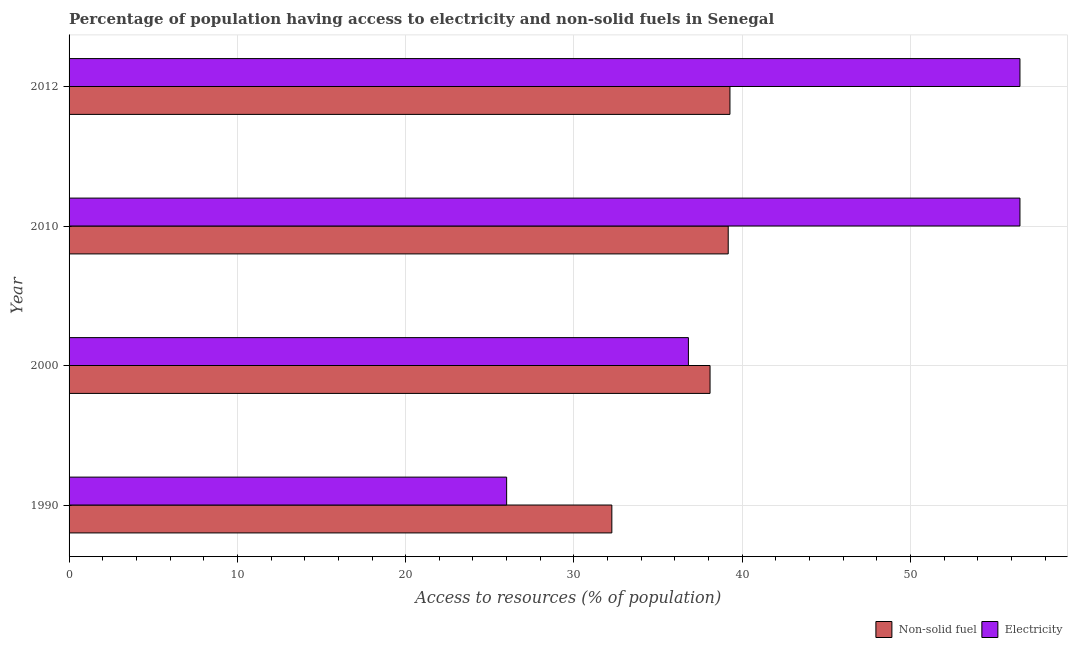Are the number of bars on each tick of the Y-axis equal?
Your answer should be very brief. Yes. How many bars are there on the 4th tick from the top?
Ensure brevity in your answer.  2. What is the percentage of population having access to non-solid fuel in 2012?
Offer a very short reply. 39.27. Across all years, what is the maximum percentage of population having access to electricity?
Offer a very short reply. 56.5. Across all years, what is the minimum percentage of population having access to non-solid fuel?
Make the answer very short. 32.25. What is the total percentage of population having access to electricity in the graph?
Make the answer very short. 175.8. What is the difference between the percentage of population having access to non-solid fuel in 2010 and that in 2012?
Keep it short and to the point. -0.1. What is the difference between the percentage of population having access to non-solid fuel in 2012 and the percentage of population having access to electricity in 1990?
Keep it short and to the point. 13.27. What is the average percentage of population having access to electricity per year?
Your answer should be compact. 43.95. In the year 2012, what is the difference between the percentage of population having access to non-solid fuel and percentage of population having access to electricity?
Ensure brevity in your answer.  -17.23. What is the ratio of the percentage of population having access to non-solid fuel in 2000 to that in 2012?
Your answer should be compact. 0.97. Is the percentage of population having access to non-solid fuel in 2000 less than that in 2012?
Make the answer very short. Yes. Is the difference between the percentage of population having access to non-solid fuel in 1990 and 2010 greater than the difference between the percentage of population having access to electricity in 1990 and 2010?
Ensure brevity in your answer.  Yes. What is the difference between the highest and the second highest percentage of population having access to non-solid fuel?
Offer a very short reply. 0.1. What is the difference between the highest and the lowest percentage of population having access to electricity?
Offer a terse response. 30.5. What does the 1st bar from the top in 2012 represents?
Offer a terse response. Electricity. What does the 2nd bar from the bottom in 2000 represents?
Provide a succinct answer. Electricity. How many bars are there?
Your answer should be compact. 8. Are all the bars in the graph horizontal?
Your answer should be very brief. Yes. How many years are there in the graph?
Your answer should be compact. 4. Does the graph contain any zero values?
Offer a terse response. No. How many legend labels are there?
Offer a very short reply. 2. How are the legend labels stacked?
Keep it short and to the point. Horizontal. What is the title of the graph?
Offer a terse response. Percentage of population having access to electricity and non-solid fuels in Senegal. What is the label or title of the X-axis?
Give a very brief answer. Access to resources (% of population). What is the label or title of the Y-axis?
Offer a very short reply. Year. What is the Access to resources (% of population) in Non-solid fuel in 1990?
Your answer should be compact. 32.25. What is the Access to resources (% of population) in Electricity in 1990?
Offer a very short reply. 26. What is the Access to resources (% of population) in Non-solid fuel in 2000?
Provide a short and direct response. 38.09. What is the Access to resources (% of population) in Electricity in 2000?
Your response must be concise. 36.8. What is the Access to resources (% of population) of Non-solid fuel in 2010?
Give a very brief answer. 39.17. What is the Access to resources (% of population) in Electricity in 2010?
Your response must be concise. 56.5. What is the Access to resources (% of population) in Non-solid fuel in 2012?
Give a very brief answer. 39.27. What is the Access to resources (% of population) in Electricity in 2012?
Provide a short and direct response. 56.5. Across all years, what is the maximum Access to resources (% of population) of Non-solid fuel?
Your response must be concise. 39.27. Across all years, what is the maximum Access to resources (% of population) of Electricity?
Offer a very short reply. 56.5. Across all years, what is the minimum Access to resources (% of population) of Non-solid fuel?
Your response must be concise. 32.25. What is the total Access to resources (% of population) in Non-solid fuel in the graph?
Your response must be concise. 148.77. What is the total Access to resources (% of population) in Electricity in the graph?
Give a very brief answer. 175.8. What is the difference between the Access to resources (% of population) of Non-solid fuel in 1990 and that in 2000?
Provide a short and direct response. -5.83. What is the difference between the Access to resources (% of population) of Electricity in 1990 and that in 2000?
Provide a short and direct response. -10.8. What is the difference between the Access to resources (% of population) of Non-solid fuel in 1990 and that in 2010?
Your answer should be compact. -6.91. What is the difference between the Access to resources (% of population) of Electricity in 1990 and that in 2010?
Make the answer very short. -30.5. What is the difference between the Access to resources (% of population) of Non-solid fuel in 1990 and that in 2012?
Provide a succinct answer. -7.02. What is the difference between the Access to resources (% of population) in Electricity in 1990 and that in 2012?
Provide a succinct answer. -30.5. What is the difference between the Access to resources (% of population) of Non-solid fuel in 2000 and that in 2010?
Provide a succinct answer. -1.08. What is the difference between the Access to resources (% of population) of Electricity in 2000 and that in 2010?
Provide a succinct answer. -19.7. What is the difference between the Access to resources (% of population) of Non-solid fuel in 2000 and that in 2012?
Give a very brief answer. -1.18. What is the difference between the Access to resources (% of population) in Electricity in 2000 and that in 2012?
Offer a terse response. -19.7. What is the difference between the Access to resources (% of population) in Non-solid fuel in 2010 and that in 2012?
Provide a succinct answer. -0.1. What is the difference between the Access to resources (% of population) in Electricity in 2010 and that in 2012?
Provide a succinct answer. 0. What is the difference between the Access to resources (% of population) in Non-solid fuel in 1990 and the Access to resources (% of population) in Electricity in 2000?
Your response must be concise. -4.55. What is the difference between the Access to resources (% of population) of Non-solid fuel in 1990 and the Access to resources (% of population) of Electricity in 2010?
Your answer should be very brief. -24.25. What is the difference between the Access to resources (% of population) in Non-solid fuel in 1990 and the Access to resources (% of population) in Electricity in 2012?
Ensure brevity in your answer.  -24.25. What is the difference between the Access to resources (% of population) in Non-solid fuel in 2000 and the Access to resources (% of population) in Electricity in 2010?
Your answer should be very brief. -18.41. What is the difference between the Access to resources (% of population) of Non-solid fuel in 2000 and the Access to resources (% of population) of Electricity in 2012?
Provide a succinct answer. -18.41. What is the difference between the Access to resources (% of population) of Non-solid fuel in 2010 and the Access to resources (% of population) of Electricity in 2012?
Your response must be concise. -17.33. What is the average Access to resources (% of population) in Non-solid fuel per year?
Keep it short and to the point. 37.19. What is the average Access to resources (% of population) in Electricity per year?
Provide a short and direct response. 43.95. In the year 1990, what is the difference between the Access to resources (% of population) in Non-solid fuel and Access to resources (% of population) in Electricity?
Offer a very short reply. 6.25. In the year 2000, what is the difference between the Access to resources (% of population) in Non-solid fuel and Access to resources (% of population) in Electricity?
Make the answer very short. 1.29. In the year 2010, what is the difference between the Access to resources (% of population) in Non-solid fuel and Access to resources (% of population) in Electricity?
Keep it short and to the point. -17.33. In the year 2012, what is the difference between the Access to resources (% of population) in Non-solid fuel and Access to resources (% of population) in Electricity?
Your response must be concise. -17.23. What is the ratio of the Access to resources (% of population) of Non-solid fuel in 1990 to that in 2000?
Your answer should be compact. 0.85. What is the ratio of the Access to resources (% of population) in Electricity in 1990 to that in 2000?
Offer a terse response. 0.71. What is the ratio of the Access to resources (% of population) of Non-solid fuel in 1990 to that in 2010?
Your answer should be very brief. 0.82. What is the ratio of the Access to resources (% of population) of Electricity in 1990 to that in 2010?
Keep it short and to the point. 0.46. What is the ratio of the Access to resources (% of population) of Non-solid fuel in 1990 to that in 2012?
Your answer should be very brief. 0.82. What is the ratio of the Access to resources (% of population) in Electricity in 1990 to that in 2012?
Offer a very short reply. 0.46. What is the ratio of the Access to resources (% of population) in Non-solid fuel in 2000 to that in 2010?
Offer a terse response. 0.97. What is the ratio of the Access to resources (% of population) of Electricity in 2000 to that in 2010?
Provide a succinct answer. 0.65. What is the ratio of the Access to resources (% of population) in Non-solid fuel in 2000 to that in 2012?
Your response must be concise. 0.97. What is the ratio of the Access to resources (% of population) of Electricity in 2000 to that in 2012?
Your answer should be very brief. 0.65. What is the ratio of the Access to resources (% of population) in Non-solid fuel in 2010 to that in 2012?
Give a very brief answer. 1. What is the ratio of the Access to resources (% of population) in Electricity in 2010 to that in 2012?
Provide a succinct answer. 1. What is the difference between the highest and the second highest Access to resources (% of population) of Non-solid fuel?
Offer a terse response. 0.1. What is the difference between the highest and the lowest Access to resources (% of population) of Non-solid fuel?
Provide a short and direct response. 7.02. What is the difference between the highest and the lowest Access to resources (% of population) of Electricity?
Offer a terse response. 30.5. 